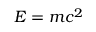<formula> <loc_0><loc_0><loc_500><loc_500>E = m c ^ { 2 }</formula> 